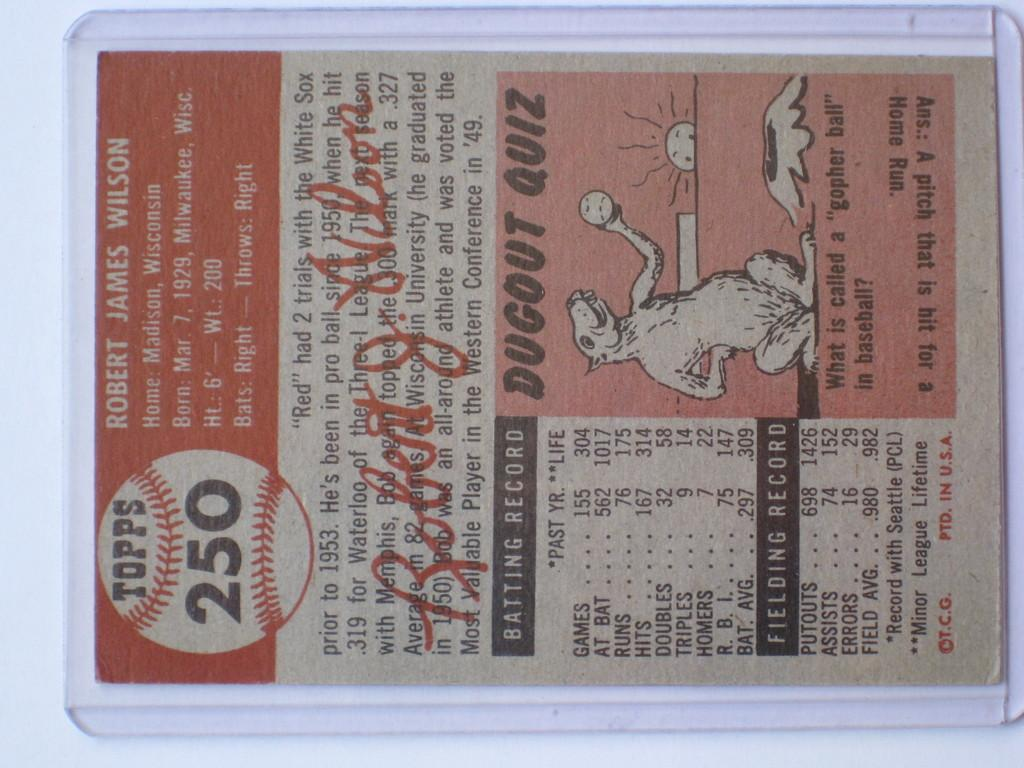What is present in the image? There is a paper in the image. What type of information is on the paper? The paper contains information about a baseball player. Where is the nest located in the image? There is no nest present in the image; it only contains a paper with information about a baseball player. 